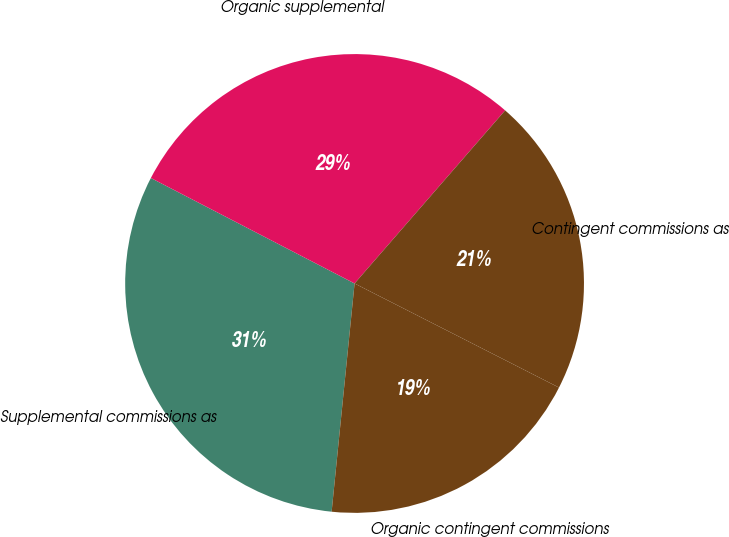<chart> <loc_0><loc_0><loc_500><loc_500><pie_chart><fcel>Supplemental commissions as<fcel>Organic supplemental<fcel>Contingent commissions as<fcel>Organic contingent commissions<nl><fcel>31.01%<fcel>28.79%<fcel>21.1%<fcel>19.1%<nl></chart> 